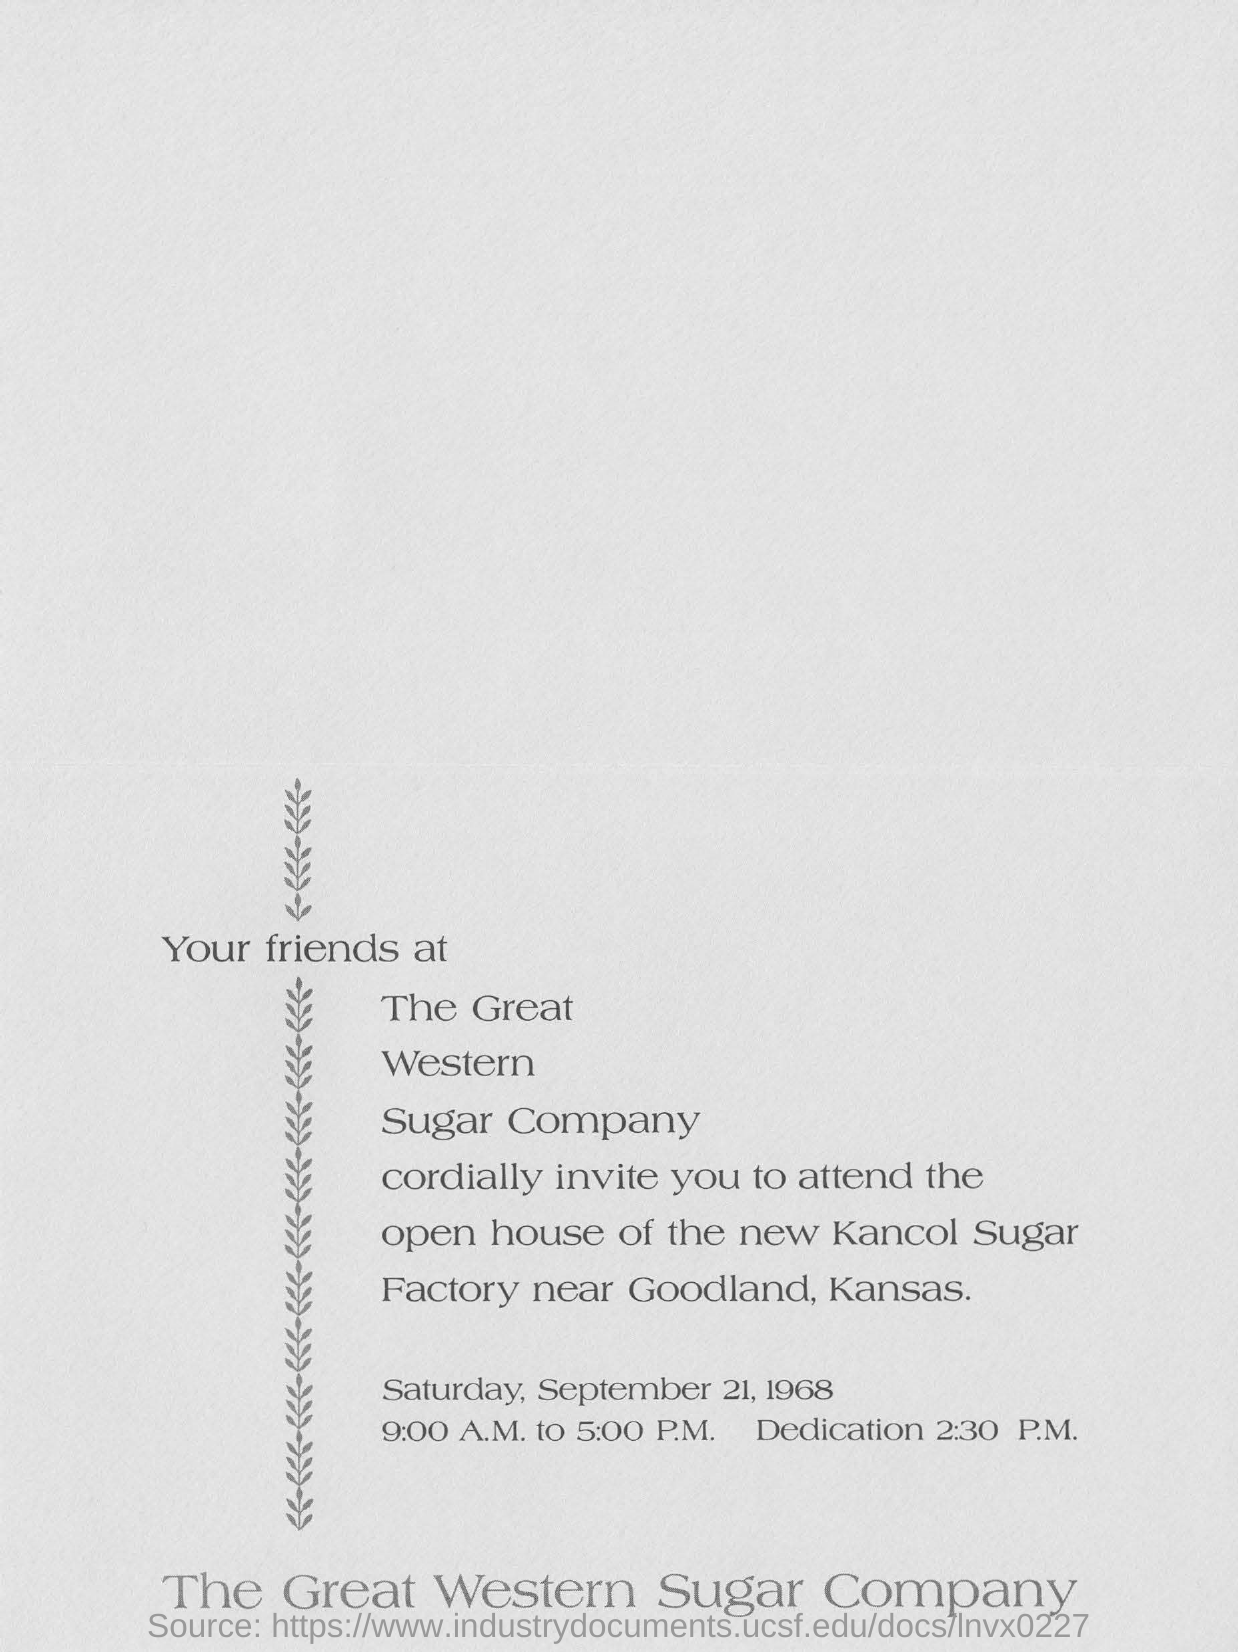Which company's invitation is this?
Your answer should be very brief. The Great Western Sugar Company. What is the date mentioned in the invitation?
Offer a terse response. Saturday, September 21, 1968. What time is the dedication?
Offer a very short reply. 2:30 P.M. 